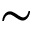<formula> <loc_0><loc_0><loc_500><loc_500>\sim</formula> 